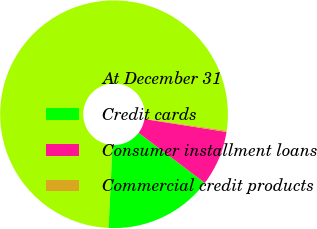Convert chart to OTSL. <chart><loc_0><loc_0><loc_500><loc_500><pie_chart><fcel>At December 31<fcel>Credit cards<fcel>Consumer installment loans<fcel>Commercial credit products<nl><fcel>76.54%<fcel>15.45%<fcel>7.82%<fcel>0.18%<nl></chart> 